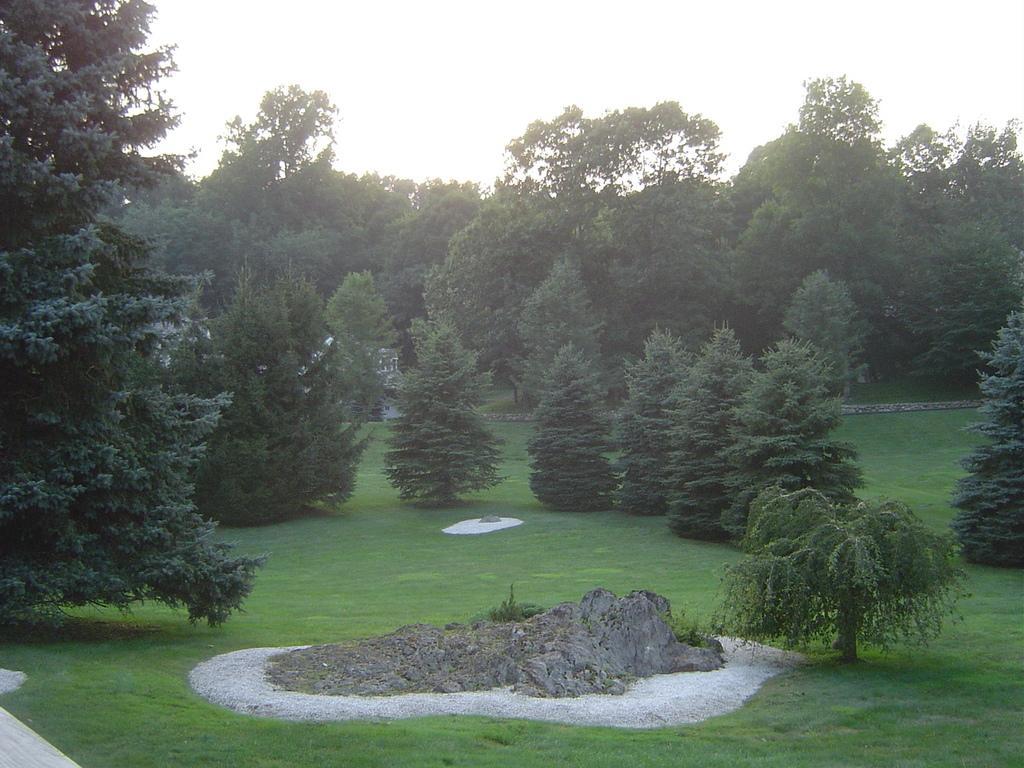In one or two sentences, can you explain what this image depicts? In this picture we can see grass, few trees and houses. 